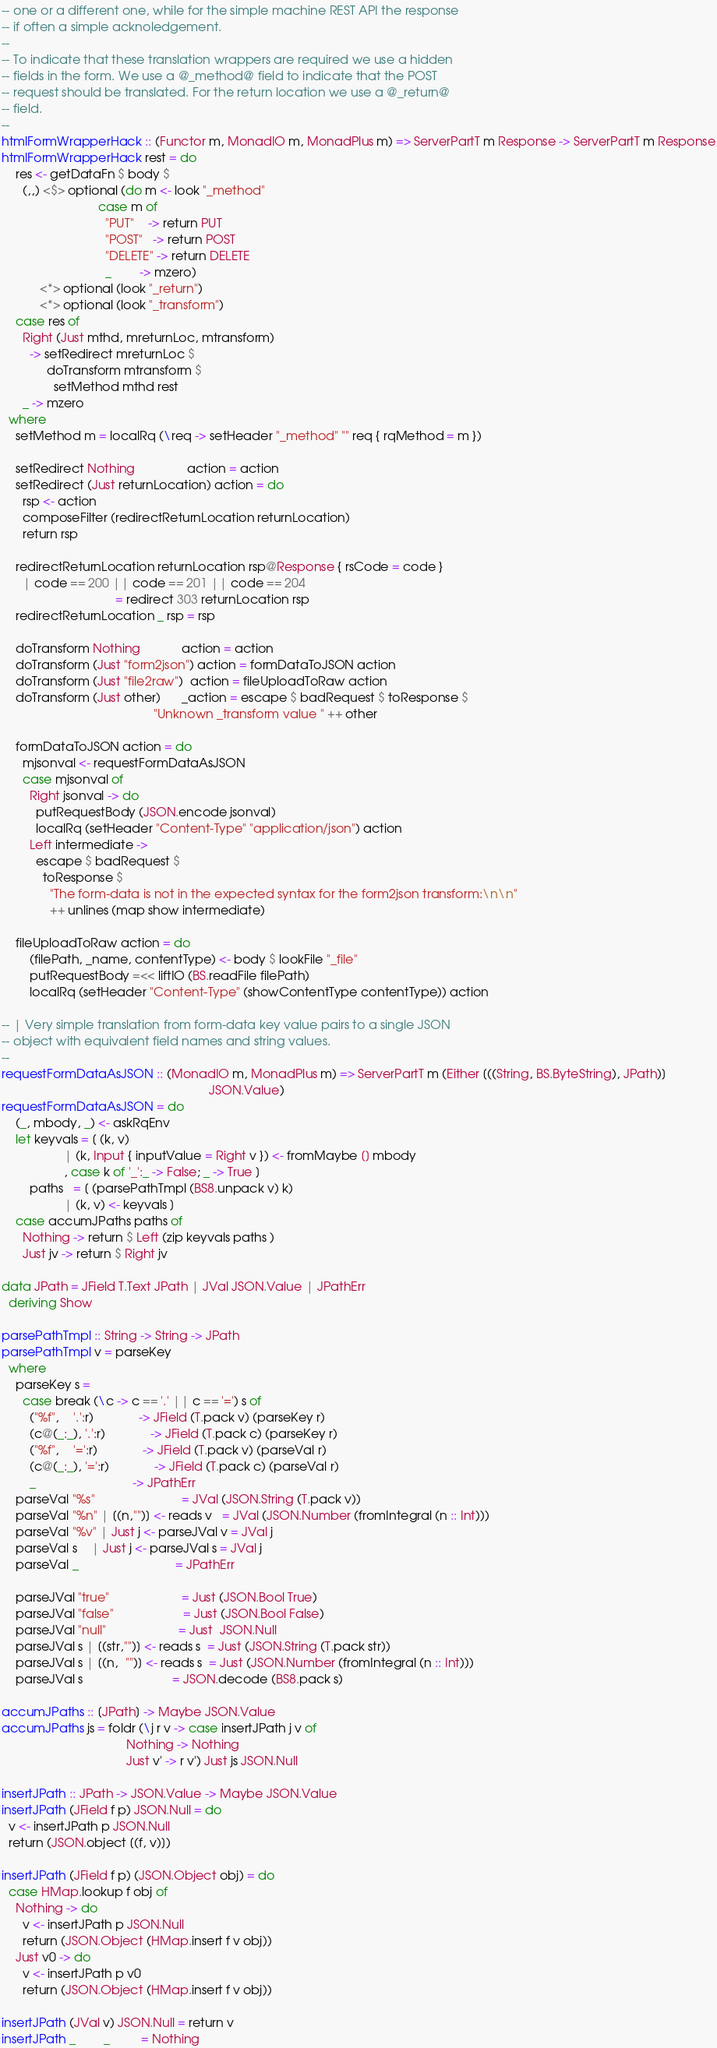<code> <loc_0><loc_0><loc_500><loc_500><_Haskell_>-- one or a different one, while for the simple machine REST API the response
-- if often a simple acknoledgement.
--
-- To indicate that these translation wrappers are required we use a hidden
-- fields in the form. We use a @_method@ field to indicate that the POST
-- request should be translated. For the return location we use a @_return@
-- field.
--
htmlFormWrapperHack :: (Functor m, MonadIO m, MonadPlus m) => ServerPartT m Response -> ServerPartT m Response
htmlFormWrapperHack rest = do
    res <- getDataFn $ body $
      (,,) <$> optional (do m <- look "_method"
                            case m of
                              "PUT"    -> return PUT
                              "POST"   -> return POST
                              "DELETE" -> return DELETE
                              _        -> mzero)
           <*> optional (look "_return")
           <*> optional (look "_transform")
    case res of
      Right (Just mthd, mreturnLoc, mtransform)
        -> setRedirect mreturnLoc $
             doTransform mtransform $
               setMethod mthd rest
      _ -> mzero
  where
    setMethod m = localRq (\req -> setHeader "_method" "" req { rqMethod = m })

    setRedirect Nothing               action = action
    setRedirect (Just returnLocation) action = do
      rsp <- action
      composeFilter (redirectReturnLocation returnLocation)
      return rsp

    redirectReturnLocation returnLocation rsp@Response { rsCode = code }
      | code == 200 || code == 201 || code == 204
                                 = redirect 303 returnLocation rsp
    redirectReturnLocation _ rsp = rsp

    doTransform Nothing            action = action
    doTransform (Just "form2json") action = formDataToJSON action
    doTransform (Just "file2raw")  action = fileUploadToRaw action
    doTransform (Just other)      _action = escape $ badRequest $ toResponse $
                                            "Unknown _transform value " ++ other

    formDataToJSON action = do
      mjsonval <- requestFormDataAsJSON
      case mjsonval of
        Right jsonval -> do
          putRequestBody (JSON.encode jsonval)
          localRq (setHeader "Content-Type" "application/json") action
        Left intermediate ->
          escape $ badRequest $
            toResponse $
              "The form-data is not in the expected syntax for the form2json transform:\n\n"
              ++ unlines (map show intermediate)

    fileUploadToRaw action = do
        (filePath, _name, contentType) <- body $ lookFile "_file"
        putRequestBody =<< liftIO (BS.readFile filePath)
        localRq (setHeader "Content-Type" (showContentType contentType)) action

-- | Very simple translation from form-data key value pairs to a single JSON
-- object with equivalent field names and string values.
--
requestFormDataAsJSON :: (MonadIO m, MonadPlus m) => ServerPartT m (Either [((String, BS.ByteString), JPath)]
                                                            JSON.Value)
requestFormDataAsJSON = do
    (_, mbody, _) <- askRqEnv
    let keyvals = [ (k, v)
                  | (k, Input { inputValue = Right v }) <- fromMaybe [] mbody
                  , case k of '_':_ -> False; _ -> True ]
        paths   = [ (parsePathTmpl (BS8.unpack v) k)
                  | (k, v) <- keyvals ]
    case accumJPaths paths of
      Nothing -> return $ Left (zip keyvals paths )
      Just jv -> return $ Right jv

data JPath = JField T.Text JPath | JVal JSON.Value | JPathErr
  deriving Show

parsePathTmpl :: String -> String -> JPath
parsePathTmpl v = parseKey
  where
    parseKey s =
      case break (\c -> c == '.' || c == '=') s of
        ("%f",    '.':r)             -> JField (T.pack v) (parseKey r)
        (c@(_:_), '.':r)             -> JField (T.pack c) (parseKey r)
        ("%f",    '=':r)             -> JField (T.pack v) (parseVal r)
        (c@(_:_), '=':r)             -> JField (T.pack c) (parseVal r)
        _                            -> JPathErr
    parseVal "%s"                         = JVal (JSON.String (T.pack v))
    parseVal "%n" | [(n,"")] <- reads v   = JVal (JSON.Number (fromIntegral (n :: Int)))
    parseVal "%v" | Just j <- parseJVal v = JVal j
    parseVal s    | Just j <- parseJVal s = JVal j
    parseVal _                            = JPathErr

    parseJVal "true"                     = Just (JSON.Bool True)
    parseJVal "false"                    = Just (JSON.Bool False)
    parseJVal "null"                     = Just  JSON.Null
    parseJVal s | [(str,"")] <- reads s  = Just (JSON.String (T.pack str))
    parseJVal s | [(n,  "")] <- reads s  = Just (JSON.Number (fromIntegral (n :: Int)))
    parseJVal s                          = JSON.decode (BS8.pack s)

accumJPaths :: [JPath] -> Maybe JSON.Value
accumJPaths js = foldr (\j r v -> case insertJPath j v of
                                    Nothing -> Nothing
                                    Just v' -> r v') Just js JSON.Null

insertJPath :: JPath -> JSON.Value -> Maybe JSON.Value
insertJPath (JField f p) JSON.Null = do
  v <- insertJPath p JSON.Null
  return (JSON.object [(f, v)])

insertJPath (JField f p) (JSON.Object obj) = do
  case HMap.lookup f obj of
    Nothing -> do
      v <- insertJPath p JSON.Null
      return (JSON.Object (HMap.insert f v obj))
    Just v0 -> do
      v <- insertJPath p v0
      return (JSON.Object (HMap.insert f v obj))

insertJPath (JVal v) JSON.Null = return v
insertJPath _        _         = Nothing
</code> 